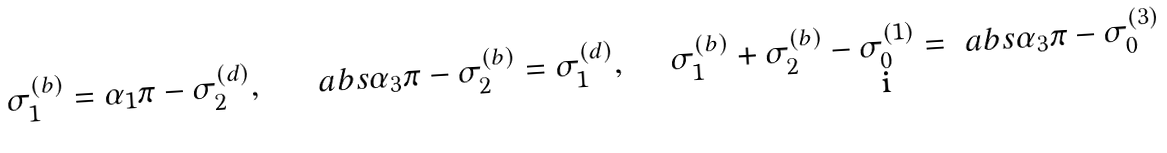Convert formula to latex. <formula><loc_0><loc_0><loc_500><loc_500>\sigma _ { 1 } ^ { ( b ) } = \alpha _ { 1 } \pi - \sigma _ { 2 } ^ { ( d ) } , \quad \ \ a b s { \alpha _ { 3 } } \pi - \sigma _ { 2 } ^ { ( b ) } = \sigma _ { 1 } ^ { ( d ) } , \quad \ \sigma _ { 1 } ^ { ( b ) } + \sigma _ { 2 } ^ { ( b ) } - \sigma _ { 0 } ^ { ( 1 ) } = \ a b s { \alpha _ { 3 } } \pi - \sigma _ { 0 } ^ { ( 3 ) }</formula> 